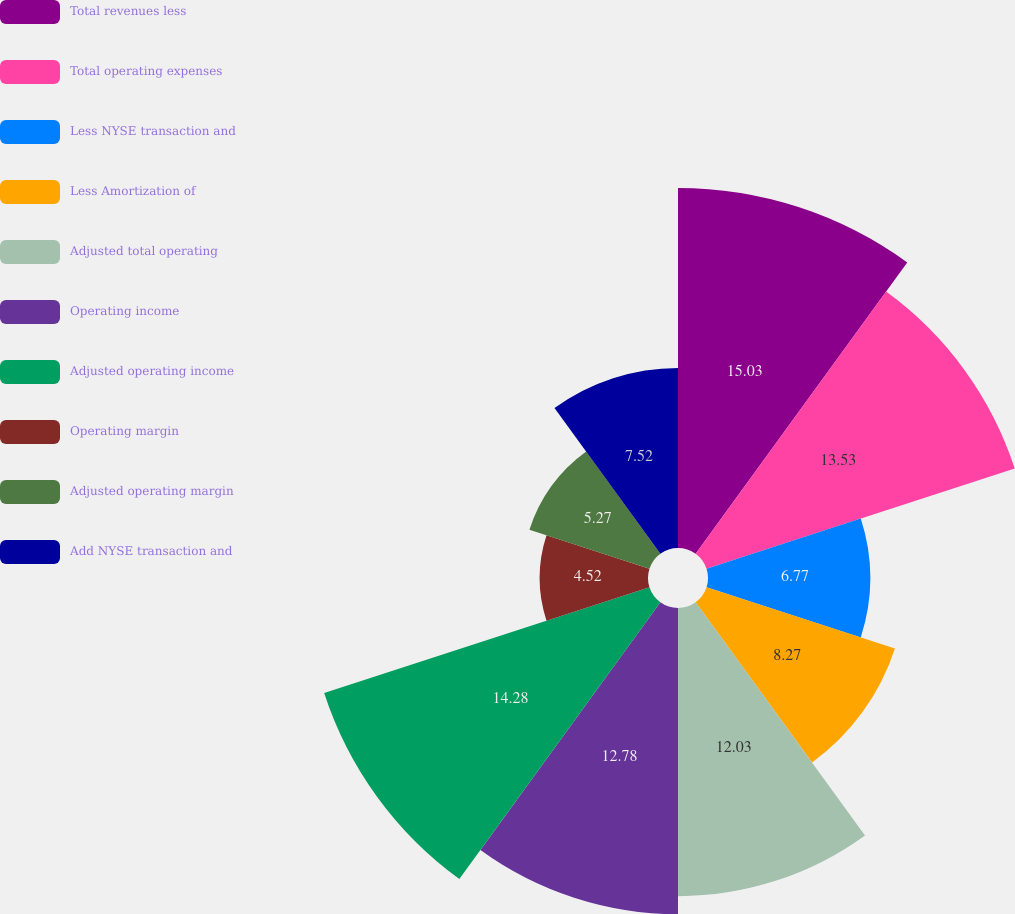<chart> <loc_0><loc_0><loc_500><loc_500><pie_chart><fcel>Total revenues less<fcel>Total operating expenses<fcel>Less NYSE transaction and<fcel>Less Amortization of<fcel>Adjusted total operating<fcel>Operating income<fcel>Adjusted operating income<fcel>Operating margin<fcel>Adjusted operating margin<fcel>Add NYSE transaction and<nl><fcel>15.03%<fcel>13.53%<fcel>6.77%<fcel>8.27%<fcel>12.03%<fcel>12.78%<fcel>14.28%<fcel>4.52%<fcel>5.27%<fcel>7.52%<nl></chart> 